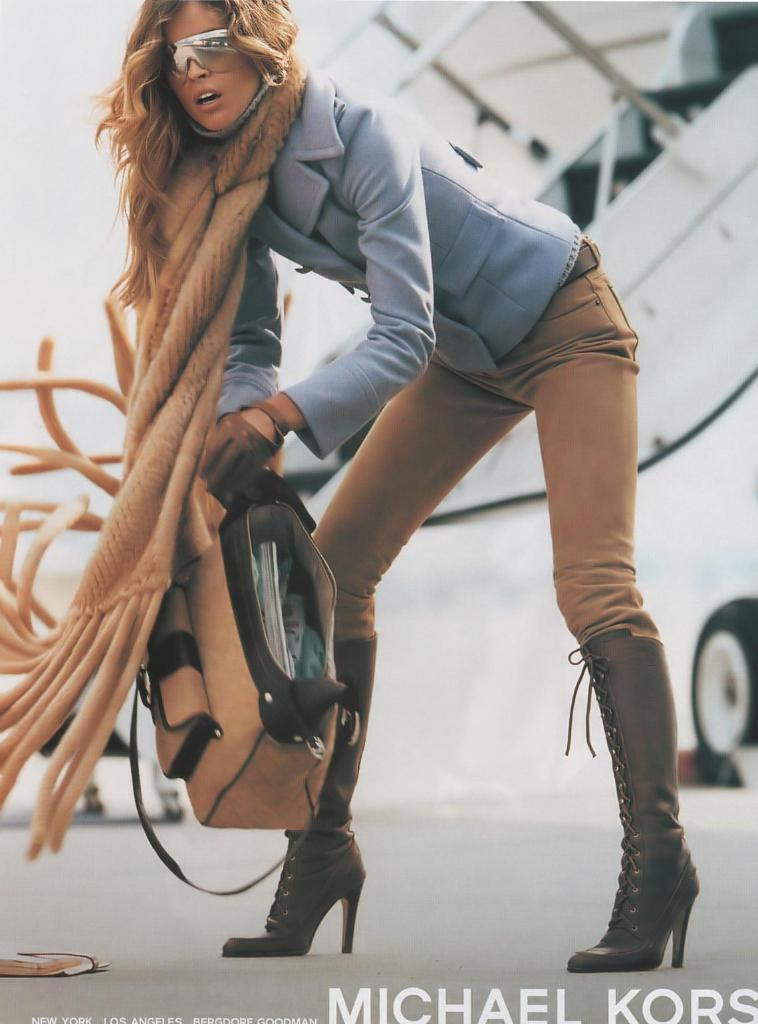What is the person in the image doing? The person is standing in the image. What is the person holding in the image? The person is holding a bag. What color is the shirt the person is wearing? The person is wearing a blue shirt. What color are the pants the person is wearing? The person is wearing cream pants. What is the color of the background in the image? The background of the image is white. How many zebras can be seen grazing in the background of the image? There are no zebras present in the image; the background is white. 